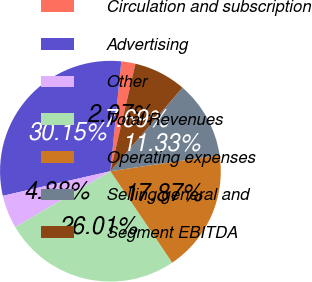Convert chart to OTSL. <chart><loc_0><loc_0><loc_500><loc_500><pie_chart><fcel>Circulation and subscription<fcel>Advertising<fcel>Other<fcel>Total Revenues<fcel>Operating expenses<fcel>Selling general and<fcel>Segment EBITDA<nl><fcel>2.07%<fcel>30.15%<fcel>4.88%<fcel>26.01%<fcel>17.87%<fcel>11.33%<fcel>7.69%<nl></chart> 